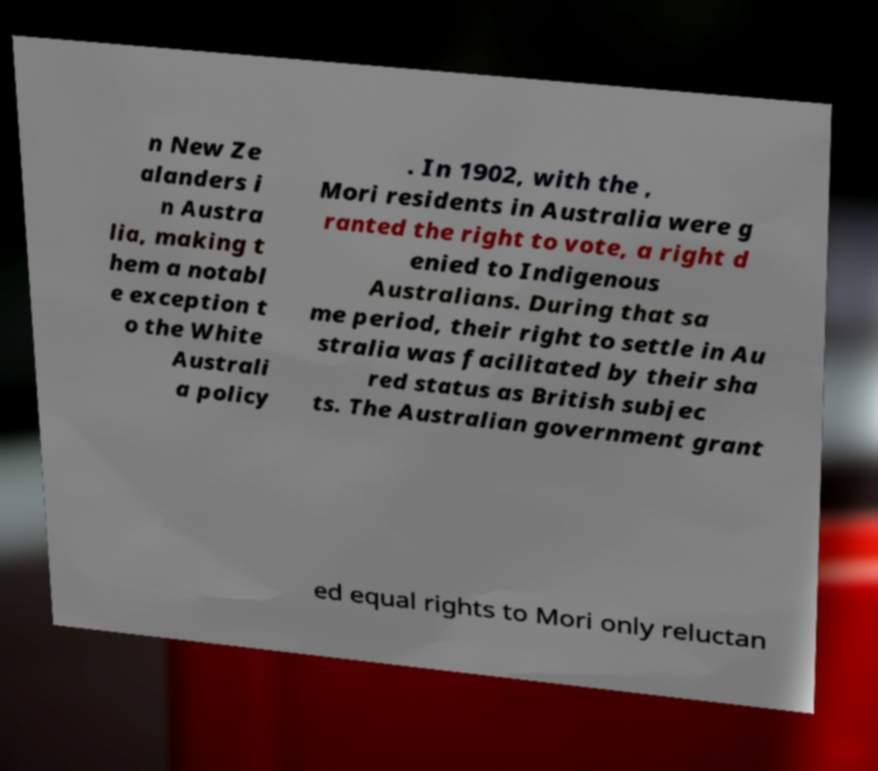Can you accurately transcribe the text from the provided image for me? n New Ze alanders i n Austra lia, making t hem a notabl e exception t o the White Australi a policy . In 1902, with the , Mori residents in Australia were g ranted the right to vote, a right d enied to Indigenous Australians. During that sa me period, their right to settle in Au stralia was facilitated by their sha red status as British subjec ts. The Australian government grant ed equal rights to Mori only reluctan 